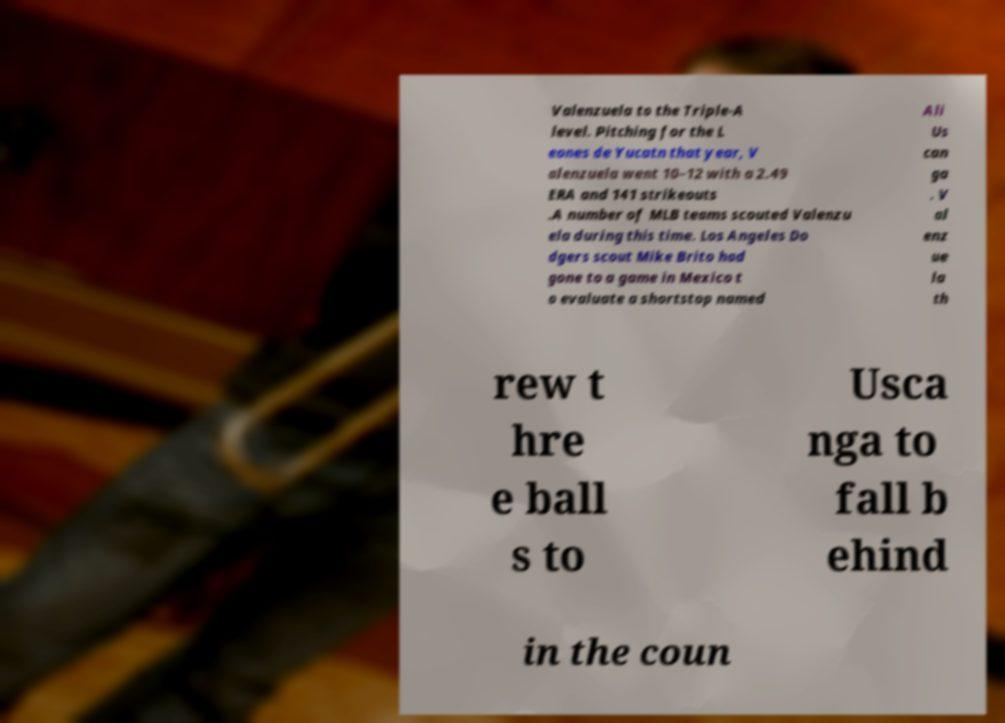Could you assist in decoding the text presented in this image and type it out clearly? Valenzuela to the Triple-A level. Pitching for the L eones de Yucatn that year, V alenzuela went 10–12 with a 2.49 ERA and 141 strikeouts .A number of MLB teams scouted Valenzu ela during this time. Los Angeles Do dgers scout Mike Brito had gone to a game in Mexico t o evaluate a shortstop named Ali Us can ga . V al enz ue la th rew t hre e ball s to Usca nga to fall b ehind in the coun 